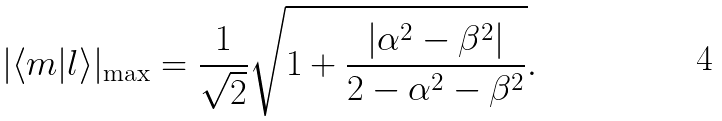Convert formula to latex. <formula><loc_0><loc_0><loc_500><loc_500>| \langle m | l \rangle | _ { \max } = \frac { 1 } { \sqrt { 2 } } \sqrt { 1 + \frac { | \alpha ^ { 2 } - \beta ^ { 2 } | } { 2 - \alpha ^ { 2 } - \beta ^ { 2 } } } .</formula> 